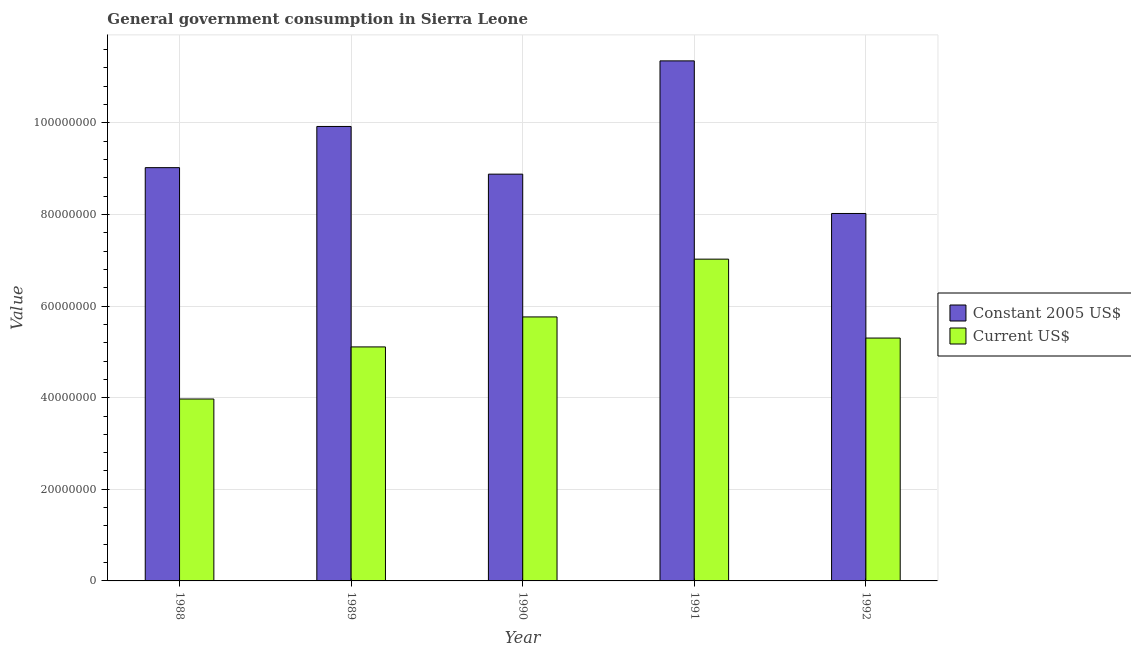Are the number of bars per tick equal to the number of legend labels?
Offer a terse response. Yes. Are the number of bars on each tick of the X-axis equal?
Offer a very short reply. Yes. How many bars are there on the 1st tick from the right?
Keep it short and to the point. 2. In how many cases, is the number of bars for a given year not equal to the number of legend labels?
Your answer should be compact. 0. What is the value consumed in current us$ in 1989?
Provide a succinct answer. 5.11e+07. Across all years, what is the maximum value consumed in constant 2005 us$?
Keep it short and to the point. 1.14e+08. Across all years, what is the minimum value consumed in constant 2005 us$?
Your answer should be very brief. 8.02e+07. What is the total value consumed in current us$ in the graph?
Give a very brief answer. 2.72e+08. What is the difference between the value consumed in constant 2005 us$ in 1988 and that in 1991?
Your response must be concise. -2.33e+07. What is the difference between the value consumed in current us$ in 1992 and the value consumed in constant 2005 us$ in 1991?
Your answer should be compact. -1.72e+07. What is the average value consumed in current us$ per year?
Offer a terse response. 5.43e+07. What is the ratio of the value consumed in current us$ in 1988 to that in 1989?
Provide a short and direct response. 0.78. What is the difference between the highest and the second highest value consumed in constant 2005 us$?
Your answer should be very brief. 1.43e+07. What is the difference between the highest and the lowest value consumed in current us$?
Give a very brief answer. 3.05e+07. Is the sum of the value consumed in current us$ in 1988 and 1991 greater than the maximum value consumed in constant 2005 us$ across all years?
Your answer should be very brief. Yes. What does the 2nd bar from the left in 1991 represents?
Provide a succinct answer. Current US$. What does the 1st bar from the right in 1990 represents?
Your answer should be compact. Current US$. Are all the bars in the graph horizontal?
Provide a succinct answer. No. Does the graph contain grids?
Provide a short and direct response. Yes. Where does the legend appear in the graph?
Provide a short and direct response. Center right. What is the title of the graph?
Give a very brief answer. General government consumption in Sierra Leone. Does "Public credit registry" appear as one of the legend labels in the graph?
Offer a very short reply. No. What is the label or title of the X-axis?
Offer a terse response. Year. What is the label or title of the Y-axis?
Provide a succinct answer. Value. What is the Value of Constant 2005 US$ in 1988?
Give a very brief answer. 9.02e+07. What is the Value of Current US$ in 1988?
Your answer should be very brief. 3.97e+07. What is the Value in Constant 2005 US$ in 1989?
Your answer should be compact. 9.92e+07. What is the Value of Current US$ in 1989?
Your response must be concise. 5.11e+07. What is the Value in Constant 2005 US$ in 1990?
Provide a short and direct response. 8.88e+07. What is the Value in Current US$ in 1990?
Provide a short and direct response. 5.76e+07. What is the Value in Constant 2005 US$ in 1991?
Offer a terse response. 1.14e+08. What is the Value in Current US$ in 1991?
Ensure brevity in your answer.  7.02e+07. What is the Value of Constant 2005 US$ in 1992?
Offer a very short reply. 8.02e+07. What is the Value in Current US$ in 1992?
Make the answer very short. 5.30e+07. Across all years, what is the maximum Value in Constant 2005 US$?
Make the answer very short. 1.14e+08. Across all years, what is the maximum Value of Current US$?
Provide a succinct answer. 7.02e+07. Across all years, what is the minimum Value of Constant 2005 US$?
Provide a succinct answer. 8.02e+07. Across all years, what is the minimum Value in Current US$?
Make the answer very short. 3.97e+07. What is the total Value of Constant 2005 US$ in the graph?
Keep it short and to the point. 4.72e+08. What is the total Value in Current US$ in the graph?
Ensure brevity in your answer.  2.72e+08. What is the difference between the Value in Constant 2005 US$ in 1988 and that in 1989?
Provide a succinct answer. -8.99e+06. What is the difference between the Value of Current US$ in 1988 and that in 1989?
Make the answer very short. -1.14e+07. What is the difference between the Value of Constant 2005 US$ in 1988 and that in 1990?
Provide a succinct answer. 1.42e+06. What is the difference between the Value of Current US$ in 1988 and that in 1990?
Offer a terse response. -1.79e+07. What is the difference between the Value in Constant 2005 US$ in 1988 and that in 1991?
Keep it short and to the point. -2.33e+07. What is the difference between the Value in Current US$ in 1988 and that in 1991?
Offer a terse response. -3.05e+07. What is the difference between the Value of Constant 2005 US$ in 1988 and that in 1992?
Provide a short and direct response. 1.00e+07. What is the difference between the Value of Current US$ in 1988 and that in 1992?
Provide a short and direct response. -1.33e+07. What is the difference between the Value in Constant 2005 US$ in 1989 and that in 1990?
Your answer should be compact. 1.04e+07. What is the difference between the Value of Current US$ in 1989 and that in 1990?
Provide a succinct answer. -6.55e+06. What is the difference between the Value in Constant 2005 US$ in 1989 and that in 1991?
Offer a very short reply. -1.43e+07. What is the difference between the Value of Current US$ in 1989 and that in 1991?
Ensure brevity in your answer.  -1.92e+07. What is the difference between the Value of Constant 2005 US$ in 1989 and that in 1992?
Offer a very short reply. 1.90e+07. What is the difference between the Value in Current US$ in 1989 and that in 1992?
Keep it short and to the point. -1.94e+06. What is the difference between the Value in Constant 2005 US$ in 1990 and that in 1991?
Provide a short and direct response. -2.47e+07. What is the difference between the Value in Current US$ in 1990 and that in 1991?
Offer a very short reply. -1.26e+07. What is the difference between the Value in Constant 2005 US$ in 1990 and that in 1992?
Offer a very short reply. 8.59e+06. What is the difference between the Value of Current US$ in 1990 and that in 1992?
Give a very brief answer. 4.61e+06. What is the difference between the Value of Constant 2005 US$ in 1991 and that in 1992?
Your response must be concise. 3.33e+07. What is the difference between the Value in Current US$ in 1991 and that in 1992?
Keep it short and to the point. 1.72e+07. What is the difference between the Value of Constant 2005 US$ in 1988 and the Value of Current US$ in 1989?
Provide a succinct answer. 3.91e+07. What is the difference between the Value of Constant 2005 US$ in 1988 and the Value of Current US$ in 1990?
Offer a terse response. 3.26e+07. What is the difference between the Value of Constant 2005 US$ in 1988 and the Value of Current US$ in 1991?
Provide a short and direct response. 2.00e+07. What is the difference between the Value in Constant 2005 US$ in 1988 and the Value in Current US$ in 1992?
Give a very brief answer. 3.72e+07. What is the difference between the Value in Constant 2005 US$ in 1989 and the Value in Current US$ in 1990?
Give a very brief answer. 4.16e+07. What is the difference between the Value of Constant 2005 US$ in 1989 and the Value of Current US$ in 1991?
Offer a terse response. 2.90e+07. What is the difference between the Value of Constant 2005 US$ in 1989 and the Value of Current US$ in 1992?
Make the answer very short. 4.62e+07. What is the difference between the Value in Constant 2005 US$ in 1990 and the Value in Current US$ in 1991?
Keep it short and to the point. 1.86e+07. What is the difference between the Value of Constant 2005 US$ in 1990 and the Value of Current US$ in 1992?
Provide a short and direct response. 3.58e+07. What is the difference between the Value in Constant 2005 US$ in 1991 and the Value in Current US$ in 1992?
Your answer should be compact. 6.05e+07. What is the average Value in Constant 2005 US$ per year?
Provide a short and direct response. 9.44e+07. What is the average Value of Current US$ per year?
Your answer should be compact. 5.43e+07. In the year 1988, what is the difference between the Value in Constant 2005 US$ and Value in Current US$?
Make the answer very short. 5.05e+07. In the year 1989, what is the difference between the Value in Constant 2005 US$ and Value in Current US$?
Your answer should be compact. 4.81e+07. In the year 1990, what is the difference between the Value of Constant 2005 US$ and Value of Current US$?
Offer a very short reply. 3.12e+07. In the year 1991, what is the difference between the Value of Constant 2005 US$ and Value of Current US$?
Provide a short and direct response. 4.33e+07. In the year 1992, what is the difference between the Value in Constant 2005 US$ and Value in Current US$?
Keep it short and to the point. 2.72e+07. What is the ratio of the Value of Constant 2005 US$ in 1988 to that in 1989?
Ensure brevity in your answer.  0.91. What is the ratio of the Value of Current US$ in 1988 to that in 1989?
Provide a succinct answer. 0.78. What is the ratio of the Value in Current US$ in 1988 to that in 1990?
Your answer should be very brief. 0.69. What is the ratio of the Value in Constant 2005 US$ in 1988 to that in 1991?
Your answer should be very brief. 0.79. What is the ratio of the Value of Current US$ in 1988 to that in 1991?
Keep it short and to the point. 0.57. What is the ratio of the Value in Constant 2005 US$ in 1988 to that in 1992?
Your answer should be compact. 1.12. What is the ratio of the Value of Current US$ in 1988 to that in 1992?
Provide a short and direct response. 0.75. What is the ratio of the Value in Constant 2005 US$ in 1989 to that in 1990?
Make the answer very short. 1.12. What is the ratio of the Value of Current US$ in 1989 to that in 1990?
Your answer should be very brief. 0.89. What is the ratio of the Value of Constant 2005 US$ in 1989 to that in 1991?
Ensure brevity in your answer.  0.87. What is the ratio of the Value of Current US$ in 1989 to that in 1991?
Keep it short and to the point. 0.73. What is the ratio of the Value in Constant 2005 US$ in 1989 to that in 1992?
Offer a very short reply. 1.24. What is the ratio of the Value in Current US$ in 1989 to that in 1992?
Offer a terse response. 0.96. What is the ratio of the Value in Constant 2005 US$ in 1990 to that in 1991?
Ensure brevity in your answer.  0.78. What is the ratio of the Value in Current US$ in 1990 to that in 1991?
Your answer should be compact. 0.82. What is the ratio of the Value in Constant 2005 US$ in 1990 to that in 1992?
Provide a short and direct response. 1.11. What is the ratio of the Value of Current US$ in 1990 to that in 1992?
Your answer should be very brief. 1.09. What is the ratio of the Value in Constant 2005 US$ in 1991 to that in 1992?
Offer a very short reply. 1.42. What is the ratio of the Value in Current US$ in 1991 to that in 1992?
Your response must be concise. 1.32. What is the difference between the highest and the second highest Value of Constant 2005 US$?
Your response must be concise. 1.43e+07. What is the difference between the highest and the second highest Value in Current US$?
Ensure brevity in your answer.  1.26e+07. What is the difference between the highest and the lowest Value in Constant 2005 US$?
Provide a short and direct response. 3.33e+07. What is the difference between the highest and the lowest Value of Current US$?
Give a very brief answer. 3.05e+07. 